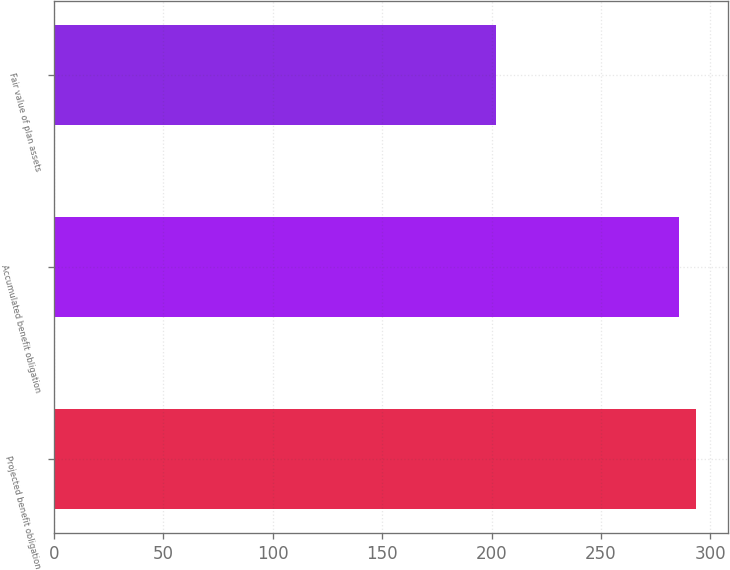<chart> <loc_0><loc_0><loc_500><loc_500><bar_chart><fcel>Projected benefit obligation<fcel>Accumulated benefit obligation<fcel>Fair value of plan assets<nl><fcel>293.42<fcel>285.46<fcel>202.1<nl></chart> 